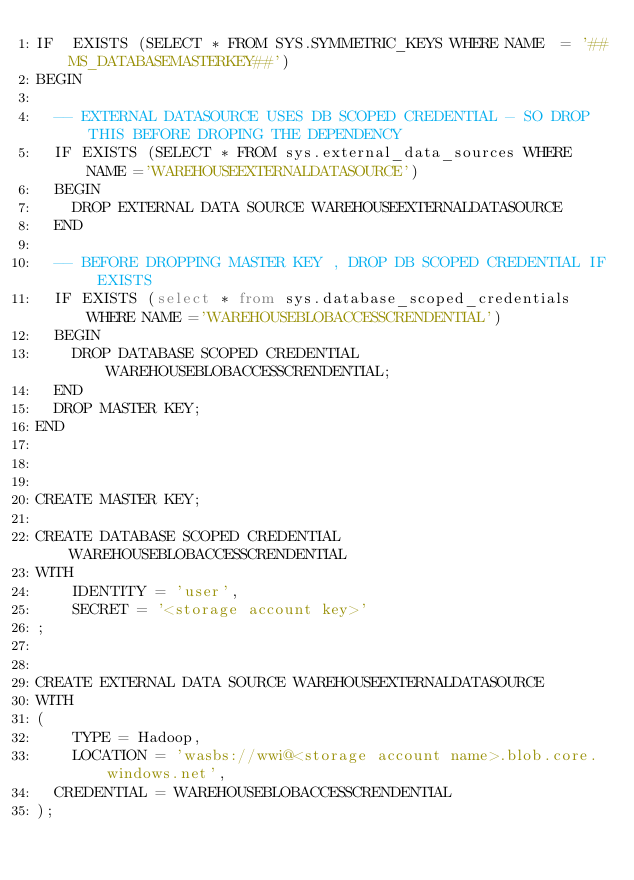<code> <loc_0><loc_0><loc_500><loc_500><_SQL_>IF  EXISTS (SELECT * FROM SYS.SYMMETRIC_KEYS WHERE NAME  = '##MS_DATABASEMASTERKEY##')
BEGIN
	
	-- EXTERNAL DATASOURCE USES DB SCOPED CREDENTIAL - SO DROP THIS BEFORE DROPING THE DEPENDENCY
	IF EXISTS (SELECT * FROM sys.external_data_sources WHERE NAME ='WAREHOUSEEXTERNALDATASOURCE')
	BEGIN
		DROP EXTERNAL DATA SOURCE WAREHOUSEEXTERNALDATASOURCE
	END 

	-- BEFORE DROPPING MASTER KEY , DROP DB SCOPED CREDENTIAL IF EXISTS
	IF EXISTS (select * from sys.database_scoped_credentials WHERE NAME ='WAREHOUSEBLOBACCESSCRENDENTIAL')
	BEGIN
		DROP DATABASE SCOPED CREDENTIAL WAREHOUSEBLOBACCESSCRENDENTIAL; 
	END	 
	DROP MASTER KEY;
END



CREATE MASTER KEY;

CREATE DATABASE SCOPED CREDENTIAL WAREHOUSEBLOBACCESSCRENDENTIAL
WITH
    IDENTITY = 'user',
    SECRET = '<storage account key>'
;


CREATE EXTERNAL DATA SOURCE WAREHOUSEEXTERNALDATASOURCE
WITH
(
    TYPE = Hadoop,
    LOCATION = 'wasbs://wwi@<storage account name>.blob.core.windows.net',
	CREDENTIAL = WAREHOUSEBLOBACCESSCRENDENTIAL
);



</code> 